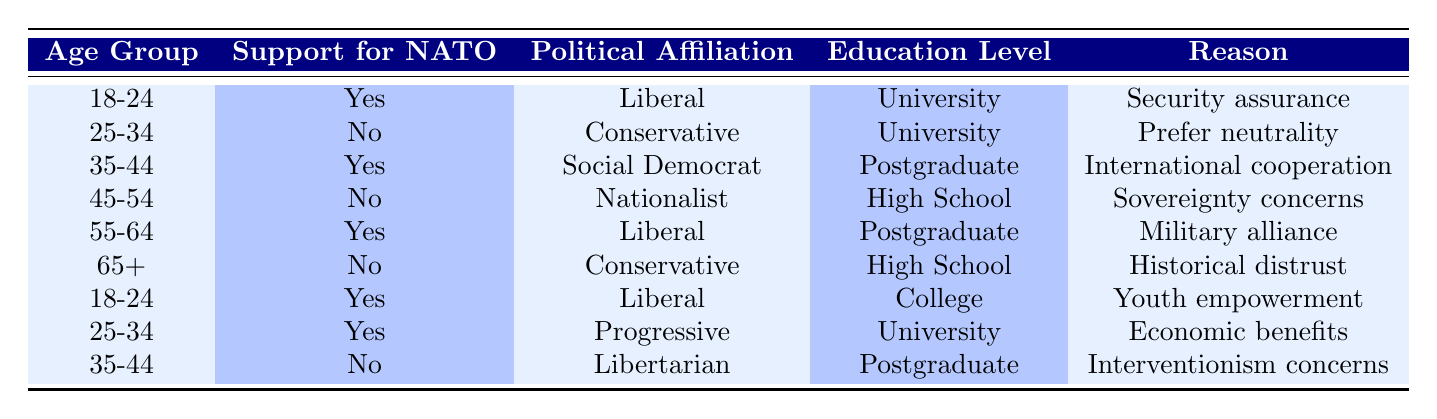What percentage of 18-24 year olds support NATO? There are two entries for the age group 18-24. Both entries indicate support for NATO ("Yes"). Therefore, the percentage of 18-24 year olds who support NATO is (2 out of 2) * 100 = 100%.
Answer: 100% How many respondents oppose NATO among the 35-44 age group? There are two entries for the 35-44 age group, one supports NATO ("Yes") and one opposes it ("No"). Therefore, there is 1 respondent opposing NATO in this age group.
Answer: 1 What is the reason for the opposition among the 45-54 group? Among the 45-54 age group, the opposition to NATO is due to "Sovereignty concerns", as indicated in the table.
Answer: Sovereignty concerns Is there any age group where a unanimous support or opposition to NATO is present? The age groups can be evaluated: 18-24 has 2 supports, but 25-34 has both support and opposition. Similarly, other age groups display mixed opinions. Therefore, there is no age group with unanimous support or opposition.
Answer: No Which political affiliation supports NATO the most among respondents aged 25-34? In the 25-34 age group, one respondent is affiliated with the Conservative party opposing NATO, and another from the Progressive party supports it. Therefore, the only political affiliation supporting NATO among this age group is Progressive.
Answer: Progressive 